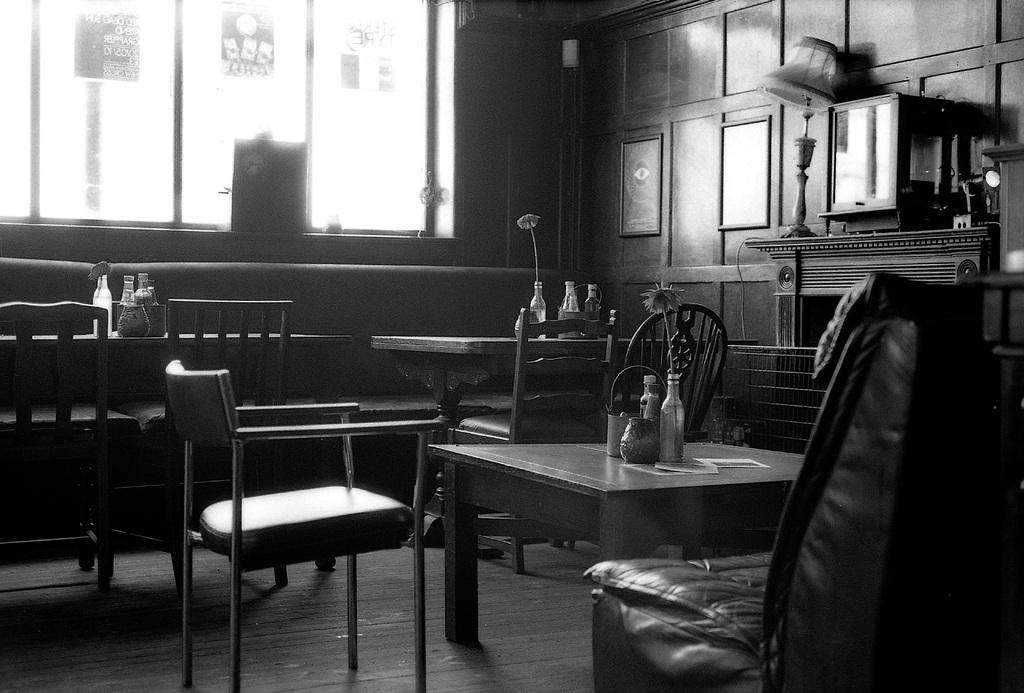What type of furniture is present in the image? There are chairs and tables in the image. What might be used for sitting or placing items in the image? The chairs and tables in the image can be used for sitting or placing items. What is placed on the table in the image? There are objects placed on the table in the image. Can you see the foot of the person sitting on the chair in the image? There is no person or foot visible in the image; it only shows chairs and tables. What type of ornament is hanging from the ceiling in the image? There is no ornament hanging from the ceiling in the image; it only shows chairs and tables. How many owls are sitting on the chairs in the image? There are no owls present in the image; it only shows chairs and tables. 